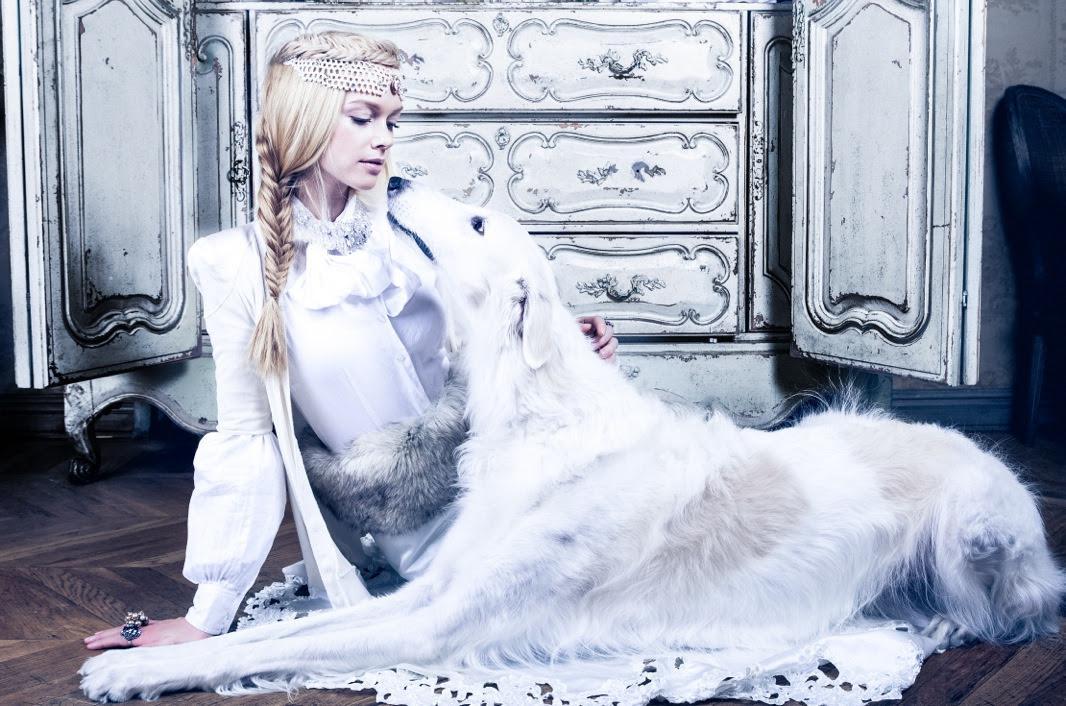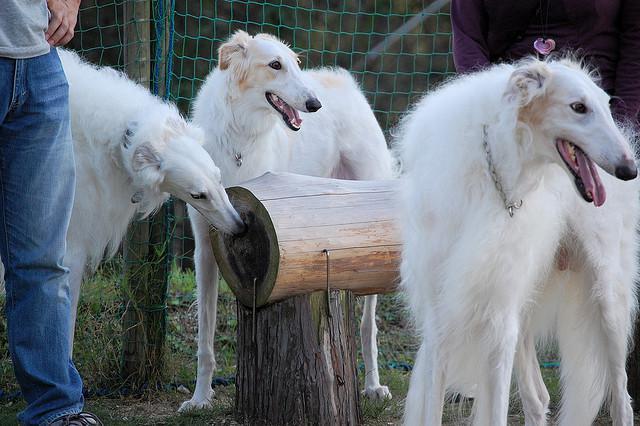The first image is the image on the left, the second image is the image on the right. Analyze the images presented: Is the assertion "There are at least two white dogs in the right image." valid? Answer yes or no. Yes. The first image is the image on the left, the second image is the image on the right. For the images shown, is this caption "there is a female sitting with a dog in one of the images" true? Answer yes or no. Yes. 